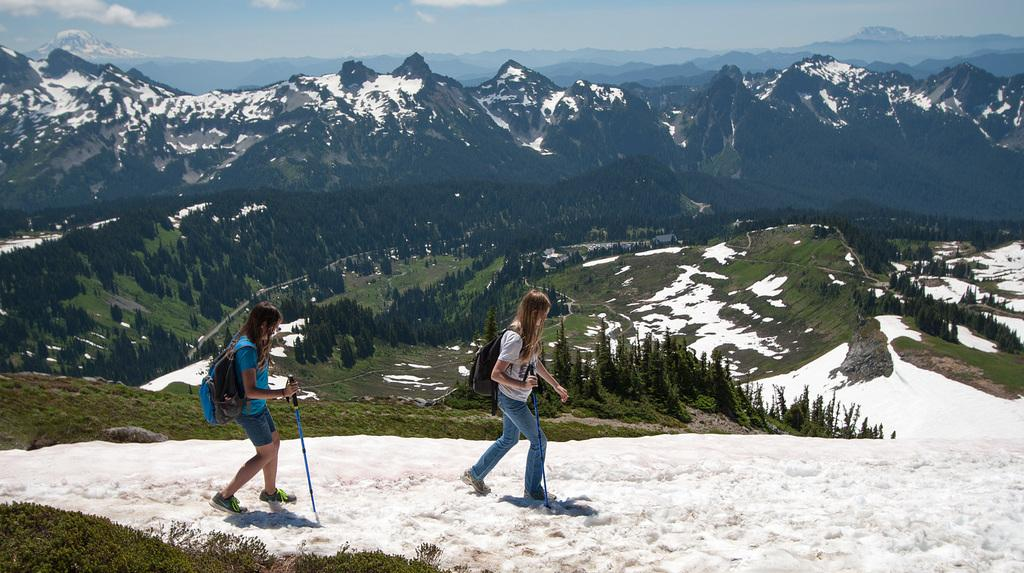What type of natural landscape is depicted in the image? There are mountains and trees in the image, indicating a natural landscape. What is the weather like in the image? There is snow visible in the image, suggesting a cold or snowy environment. What are the two people in the image doing? The two people are walking in the image. What are the people holding while walking? The people are holding sticks in the image. What are the people wearing on their backs? The people are wearing bags in the image. What is the color of the sky in the image? The sky is blue and white in color in the image. What type of bread can be seen in the image? There is no bread present in the image. What is the head of the mountain doing in the image? There is no head or personification of the mountain in the image; it is a natural landscape feature. 